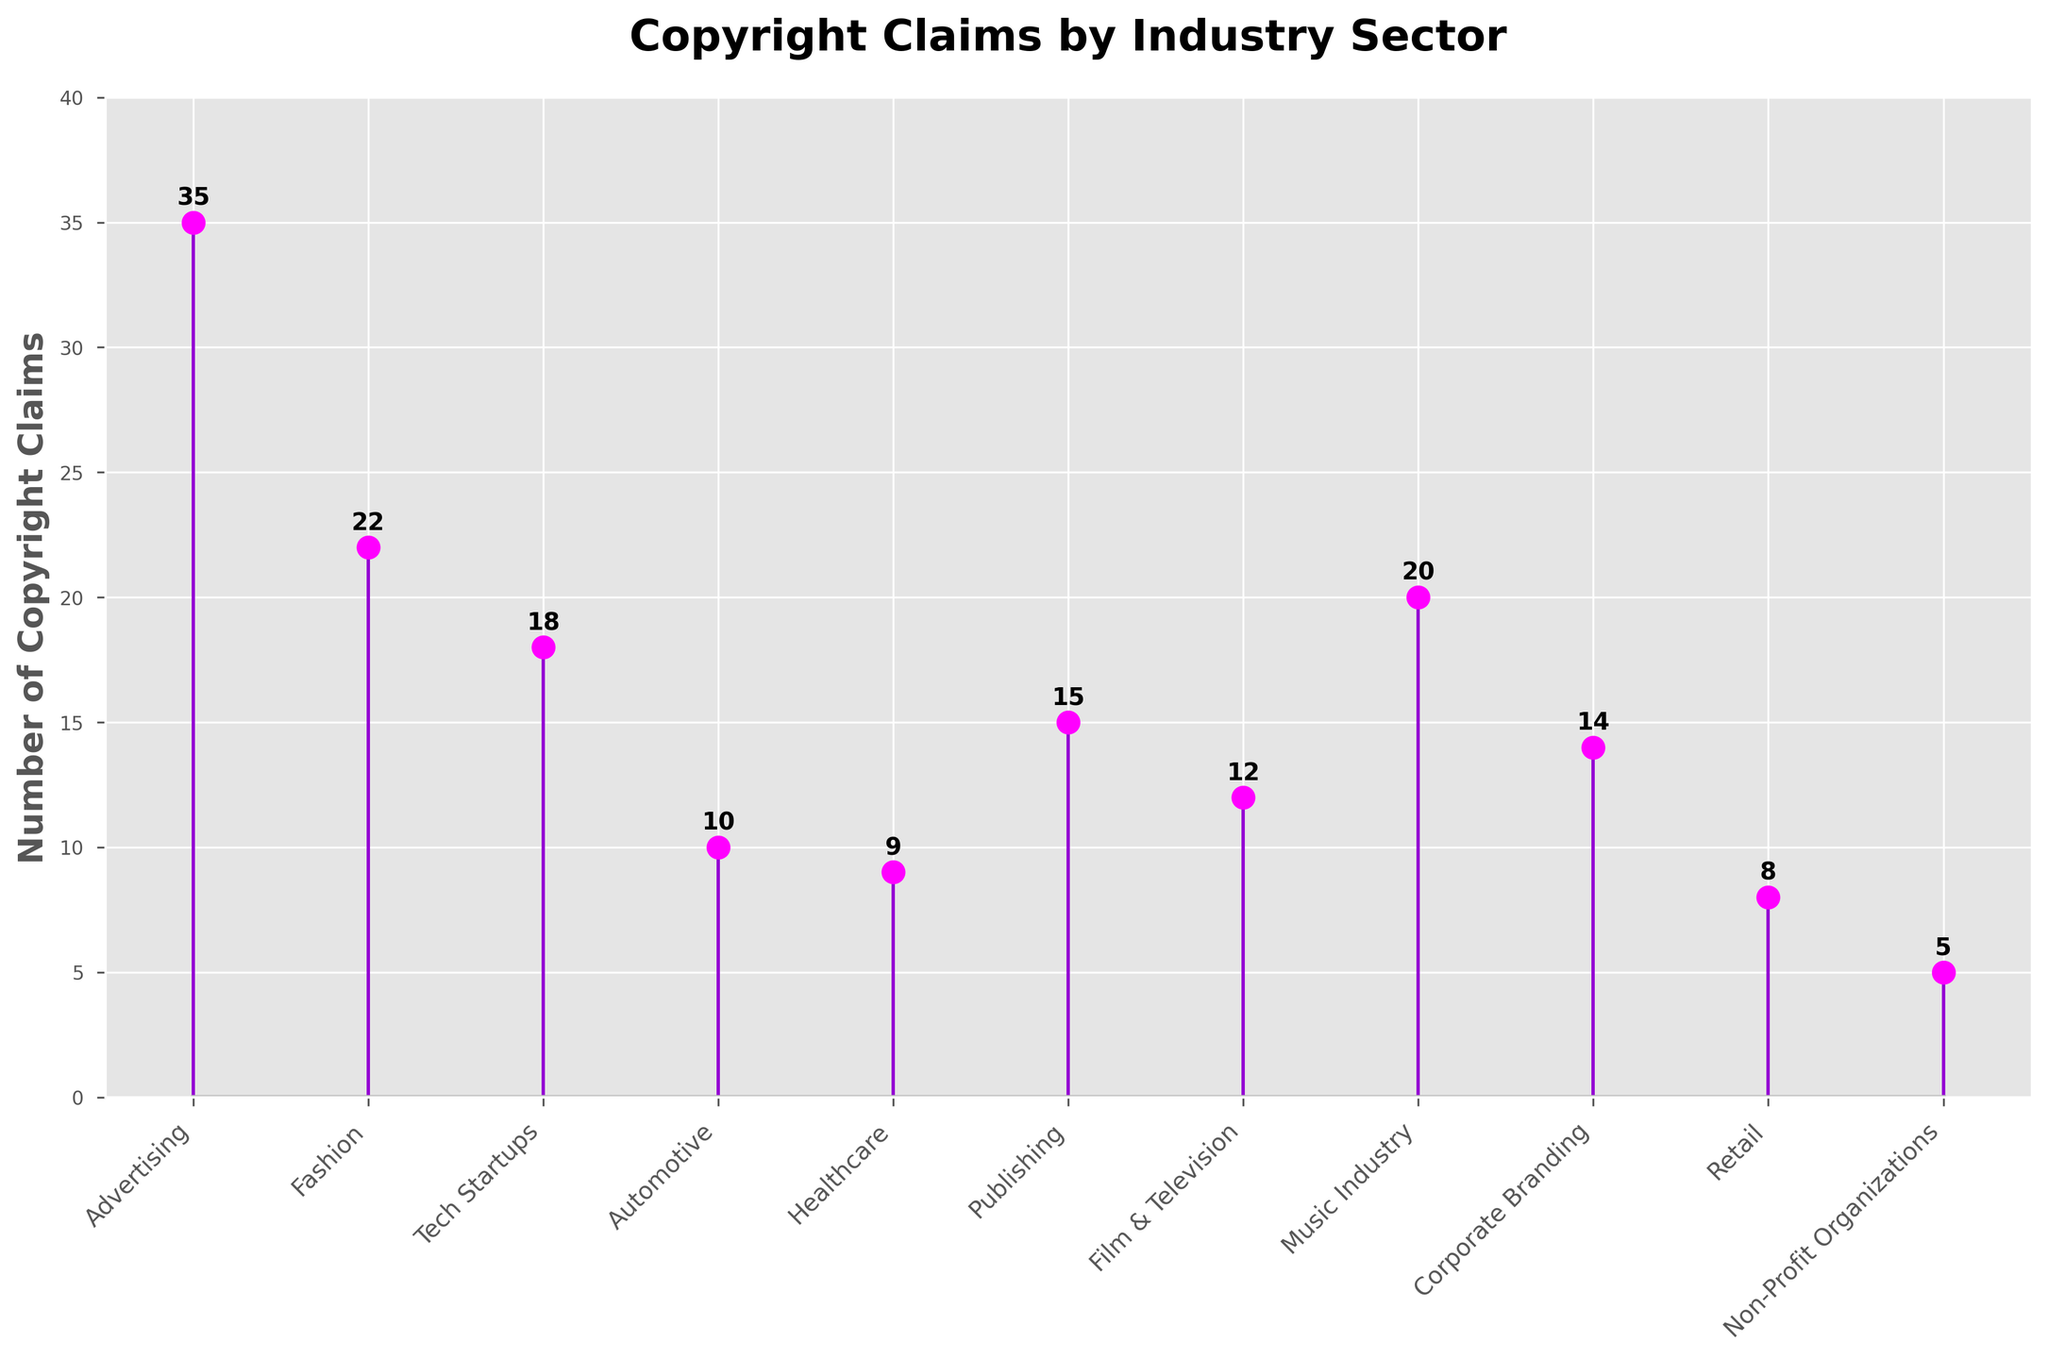What's the title of the figure? The title of the figure is located at the top of the plot and typically describes the main topic or purpose of the plot. In this case, it is visible at the top center.
Answer: Copyright Claims by Industry Sector Which industry sector has the highest number of copyright claims? The industry sector with the highest number of copyright claims will be represented by the stem reaching the highest value on the vertical axis.
Answer: Advertising How many copyright claims does the Healthcare sector have? Locate the "Healthcare" label along the horizontal axis, then identify the corresponding value on the vertical axis. This value represents the number of copyright claims for the Healthcare sector.
Answer: 9 What is the total number of copyright claims for the Publishing, Film & Television, and Music Industry sectors combined? Sum the values corresponding to the Publishing, Film & Television, and Music Industry labels found on the horizontal axis. These values represent the number of copyright claims for each respective sector.
Answer: 15 + 12 + 20 = 47 How many industry sectors have fewer than 10 copyright claims? Count the number of industry sectors where the value on the vertical axis (number of copyright claims) is less than 10.
Answer: 3 (Automotive, Retail, Non-Profit Organizations) Which sector has more copyright claims: Fashion or Tech Startups? Compare the values corresponding to the Fashion and Tech Startups labels on the horizontal axis. The taller stem indicates the sector with more claims.
Answer: Fashion What's the difference in the number of copyright claims between Advertising and the Non-Profit Organizations sectors? Subtract the value corresponding to the Non-Profit Organizations sector from the value corresponding to the Advertising sector on the vertical axis.
Answer: 35 - 5 = 30 What's the average number of copyright claims across all industry sectors? Sum the values for copyright claims from all industry sectors and divide by the number of sectors (11 in total). (35 + 22 + 18 + 10 + 9 + 15 + 12 + 20 + 14 + 8 + 5) / 11 = 168 / 11 = 15.27
Answer: 15.27 Identify the sector with the median number of copyright claims. When the data points are arranged in ascending order: 5, 8, 9, 10, 12, 14, 15, 18, 20, 22, 35, the median is the middle value (6th value), which corresponds to the Corporate Branding sector.
Answer: Corporate Branding In which sector is the number of copyright claims closest to the average number of claims across all sectors? Calculate the average number of copyright claims (15.27), then identify which sector's claim number is closest to this average.
Answer: Publishing (15) 